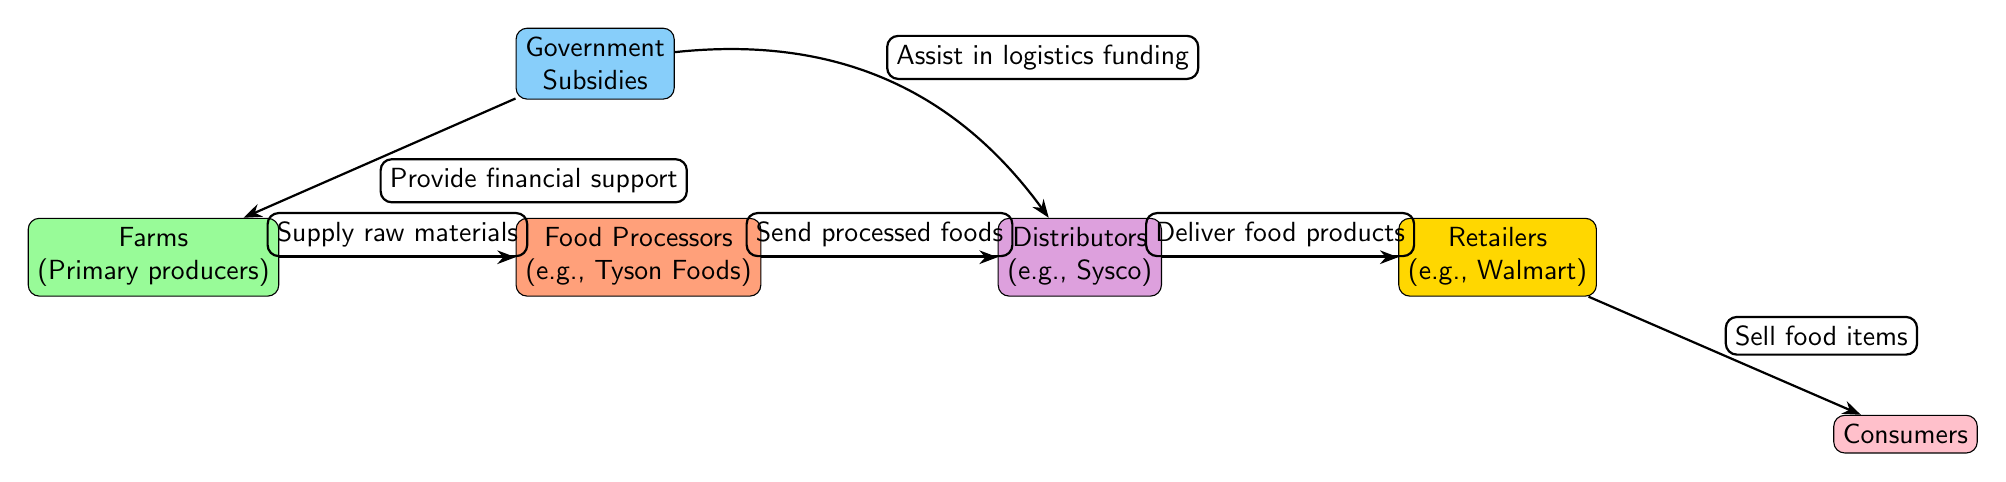What are the primary producers in the diagram? The node labeled "Farms" refers to primary producers in the food chain.
Answer: Farms How many edges are there in the diagram? Counting the arrows connecting the nodes, there are six edges shown in the food chain.
Answer: 6 What role do distributors play in this food chain? The edge from "Distributors" to "Retailers" shows that distributors deliver food products to retailers, indicating their role in the supply chain.
Answer: Deliver food products How does the government assist distributors according to the diagram? The diagram shows an edge from "Government Subsidies" to "Distributors" labeled "Assist in logistics funding," illustrating the government's supportive role.
Answer: Assist in logistics funding Which node receives processed foods from the food processors? The arrow indicates that "Distributors" receive processed foods from "Food Processors."
Answer: Distributors What kind of support do farms receive from the government? The edge from "Government Subsidies" to "Farms" is labeled "Provide financial support," indicating the type of assistance provided to farms.
Answer: Provide financial support What is the final step in the food supply chain depicted in the diagram? The last node in the flow is "Consumers," which shows that consumers are the final recipients of food in the supply chain.
Answer: Consumers Which node directly supplies raw materials to food processors? The flow arrow from "Farms" to "Food Processors" indicates that farms directly supply raw materials to food processors.
Answer: Supply raw materials 